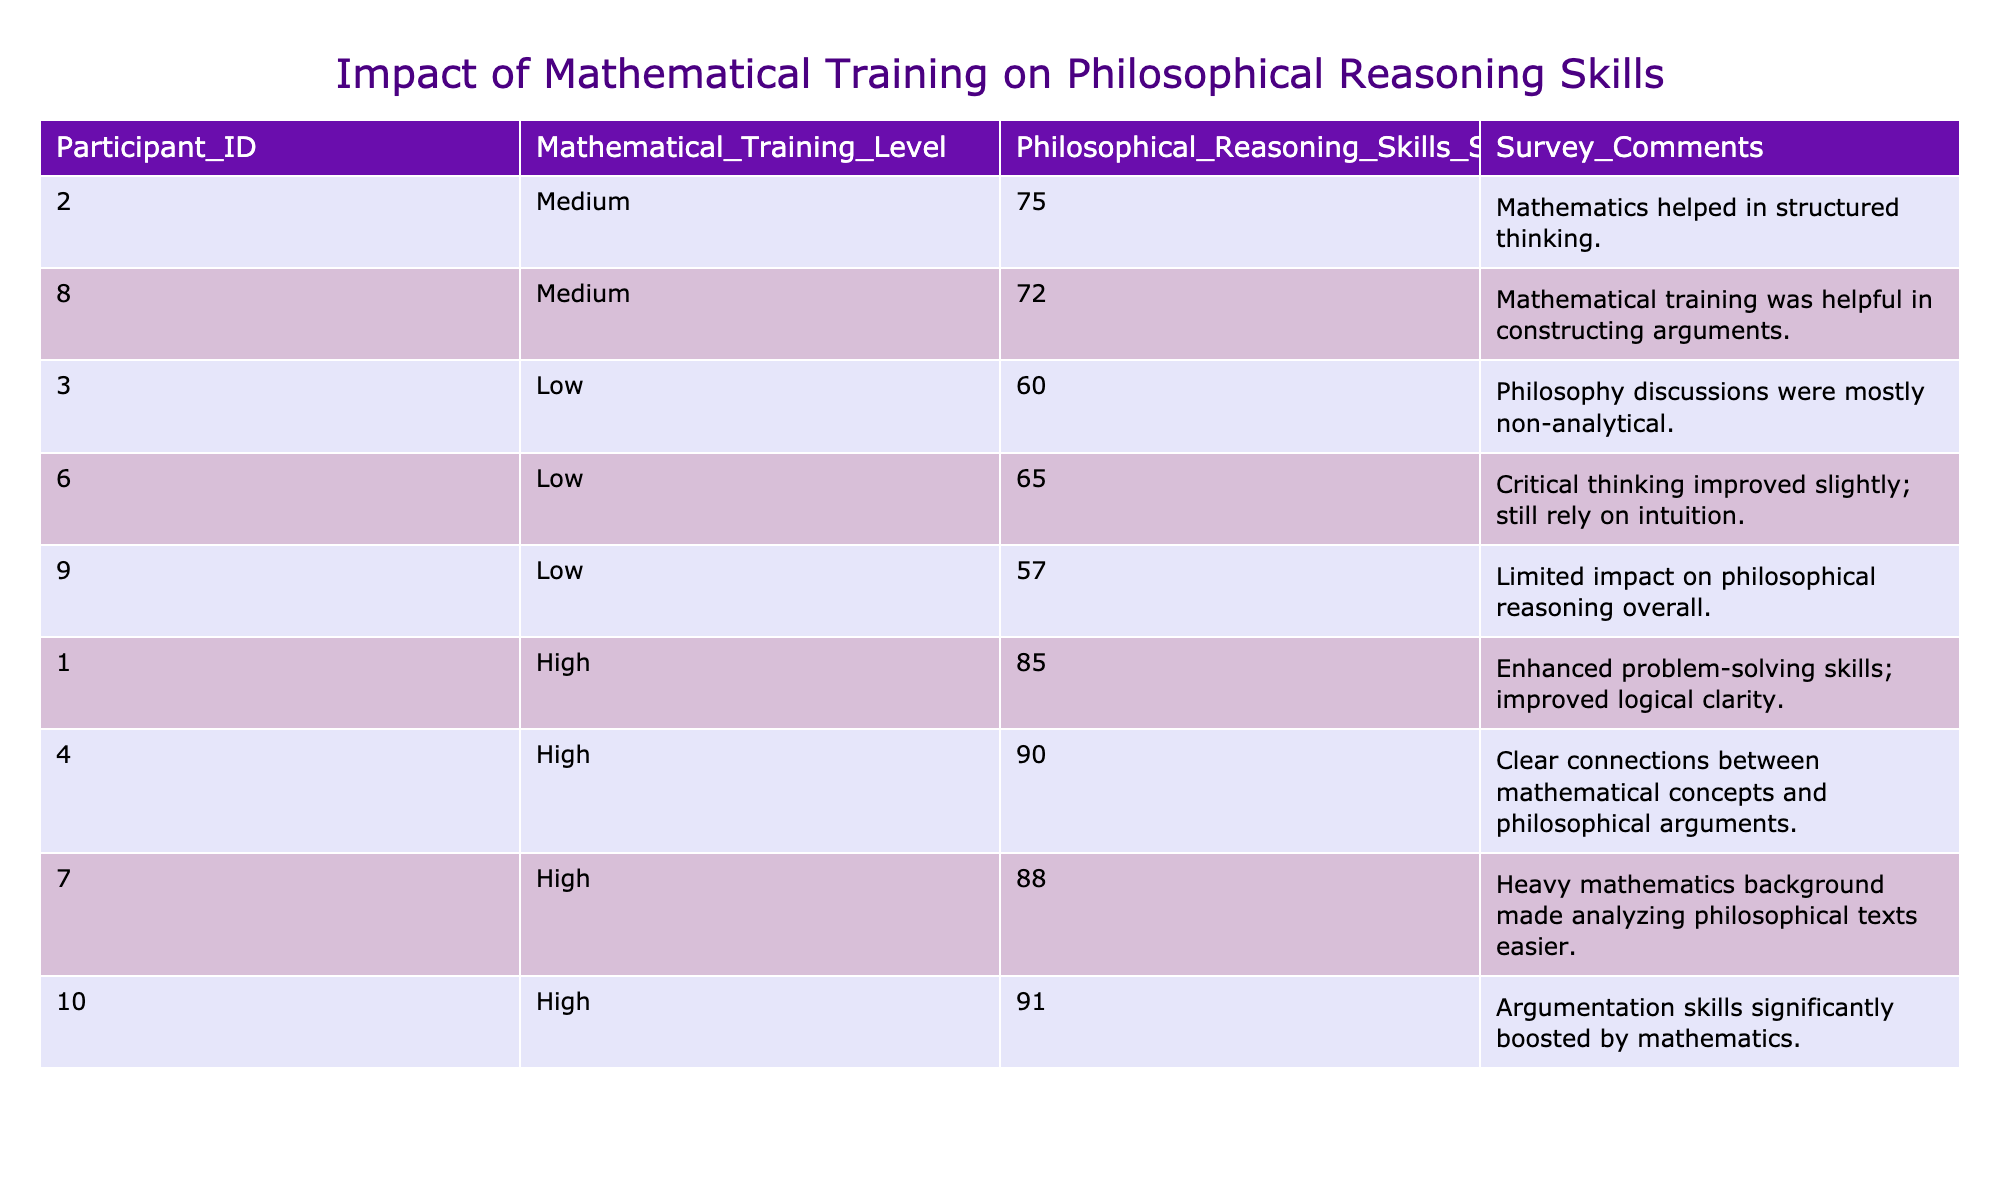What is the Philosophical Reasoning Skills Score for participants with High mathematical training? The table shows three participants with High mathematical training levels: Participant 1 has a score of 85, Participant 4 has a score of 90, Participant 7 has a score of 88, and Participant 10 has a score of 91. The scores for High training are 85, 90, 88, and 91.
Answer: 85, 90, 88, 91 What were the Survey Comments from participants with Low mathematical training? There are three participants with Low training levels: Participant 3 mentions "Philosophy discussions were mostly non-analytical," Participant 6 states "Critical thinking improved slightly; still rely on intuition," and Participant 9 notes "Limited impact on philosophical reasoning overall." Collectively, the comments are: "Philosophy discussions were mostly non-analytical," "Critical thinking improved slightly; still rely on intuition," and "Limited impact on philosophical reasoning overall."
Answer: "Philosophy discussions were mostly non-analytical," "Critical thinking improved slightly; still rely on intuition," "Limited impact on philosophical reasoning overall." What is the average Philosophical Reasoning Skills Score for participants with Medium mathematical training? The scores for participants with Medium training are 75 and 72. To find the average, add these scores: 75 + 72 = 147, and then divide by the number of participants (2). The average score is 147 / 2 = 73.5.
Answer: 73.5 Did any participant with High mathematical training report a negative impact on their philosophical reasoning skills? None of the comments from participants with High training reflect a negative impact; they all indicate enhanced skills or improvement. Therefore, the answer is no.
Answer: No Which mathematical training level corresponds to the highest average Philosophical Reasoning Skills Score? To find this, we calculate the average scores for each training level: High: (85 + 90 + 88 + 91) / 4 = 88.5, Medium: (75 + 72) / 2 = 73.5, Low: (60 + 65 + 57) / 3 = 60.67. The highest average score of 88.5 corresponds to the High mathematical training level.
Answer: High What percentage of participants reported an overall positive impact from their mathematical training (considering "enhanced," "improved," or "significantly boosted")? Counting positive comments: Participants 1, 2, 4, 7, 8, and 10 noted improvements, totaling 6. There are 10 participants in total, so the percentage is (6 / 10) * 100 = 60%.
Answer: 60% What is the difference in Philosophical Reasoning Skills Scores between the highest and lowest scoring participants? The highest score is 91 (Participant 10) and the lowest score is 57 (Participant 9). To find the difference, we subtract the lowest score from the highest score: 91 - 57 = 34.
Answer: 34 Is there a trend indicating that participants with higher mathematical training levels tend to have higher Philosophical Reasoning Skills Scores? Looking at the data: High scores are consistently above Medium and Low scores. Participants with High training scored 85, 90, 88, and 91, while Medium scored 75 and 72, and Low scored 60, 65, and 57. This indicates a trend that suggests participants with higher training levels tend to score higher.
Answer: Yes 